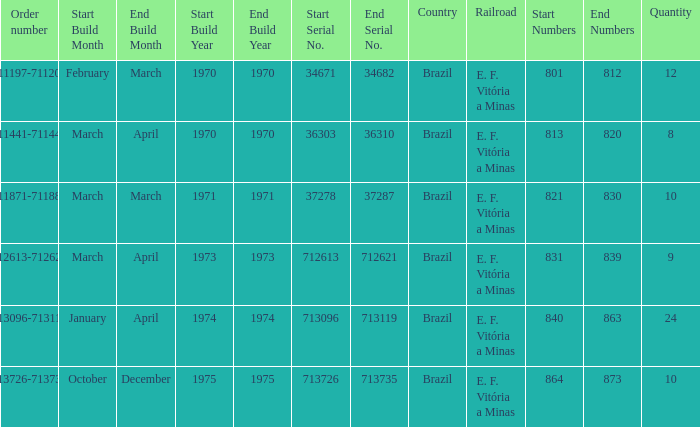What country has the order number 711871-711880? Brazil. 